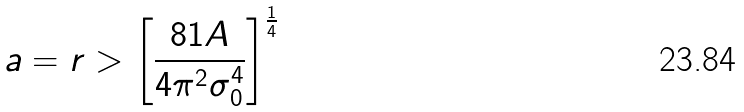Convert formula to latex. <formula><loc_0><loc_0><loc_500><loc_500>a = r > \left [ \frac { 8 1 A } { 4 \pi ^ { 2 } \sigma _ { 0 } ^ { 4 } } \right ] ^ { \frac { 1 } { 4 } }</formula> 